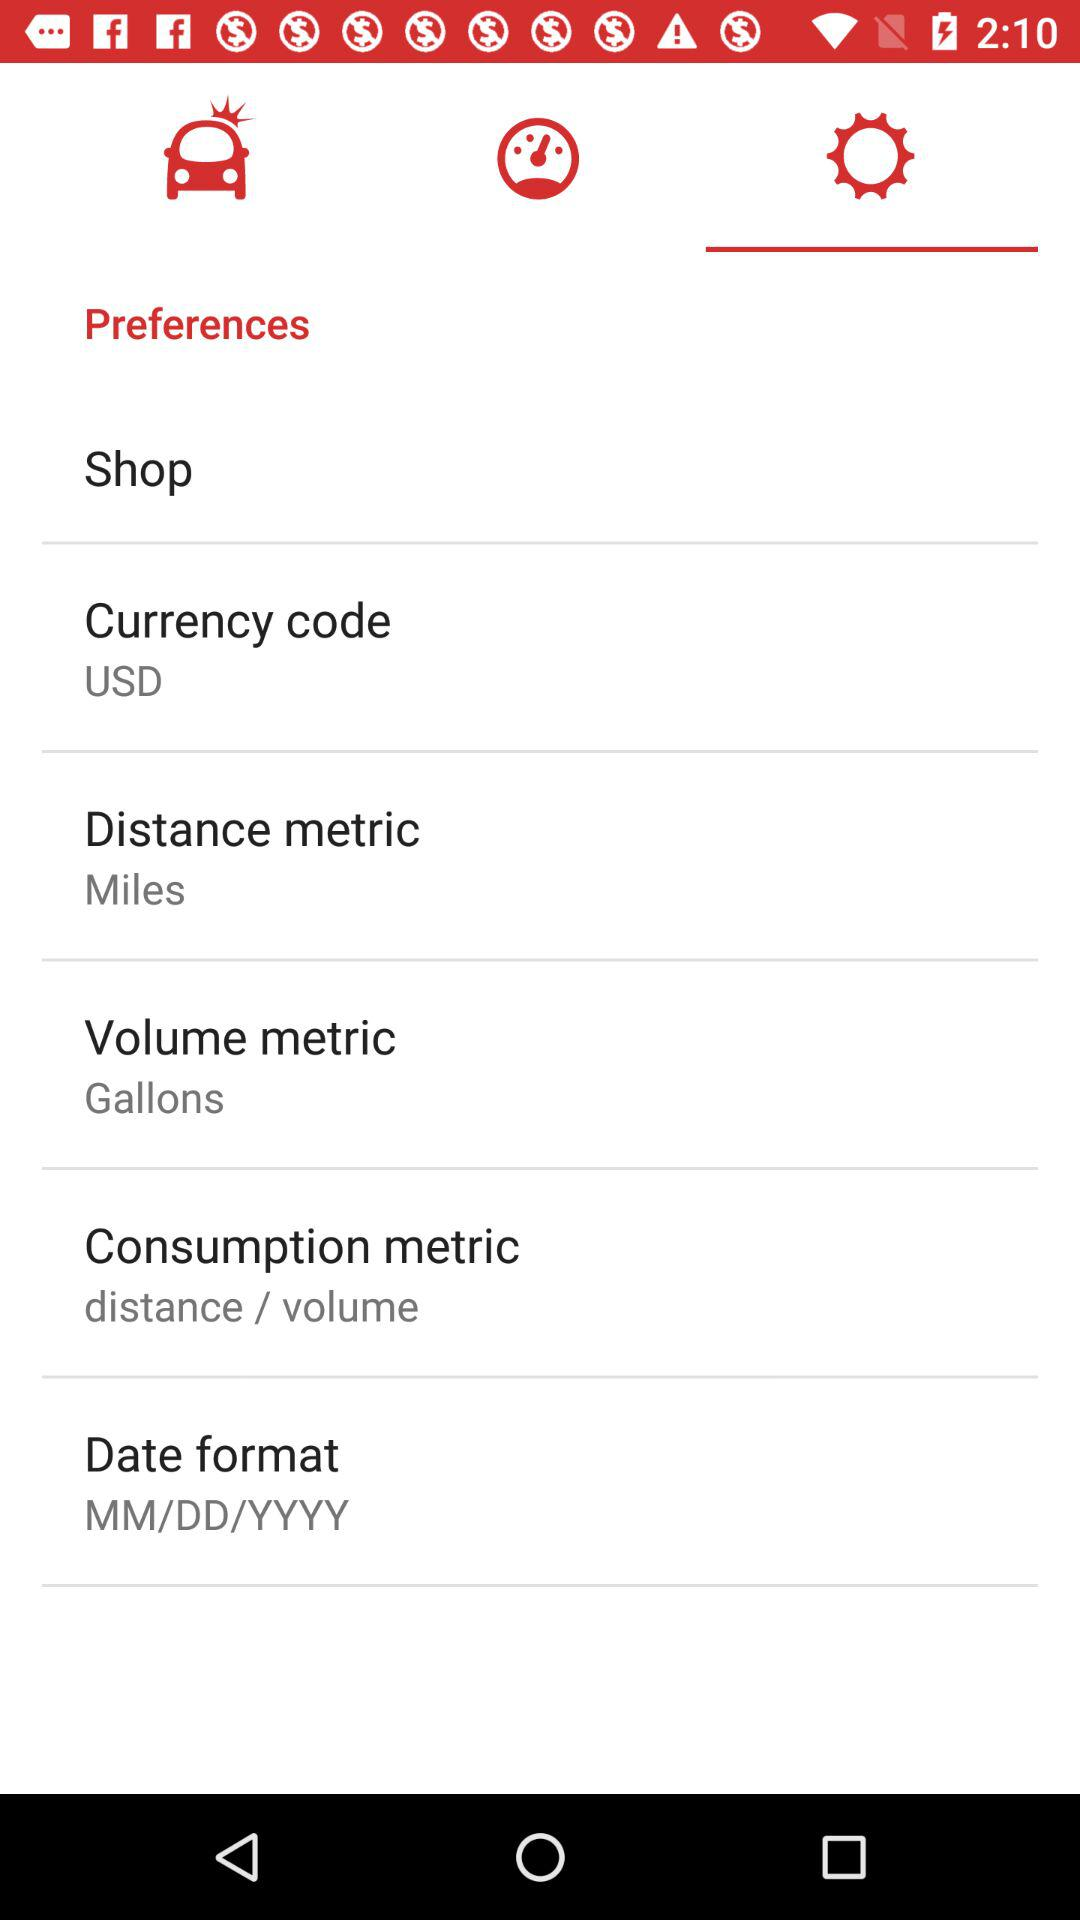What is the given currency code? The given currency code is USD. 